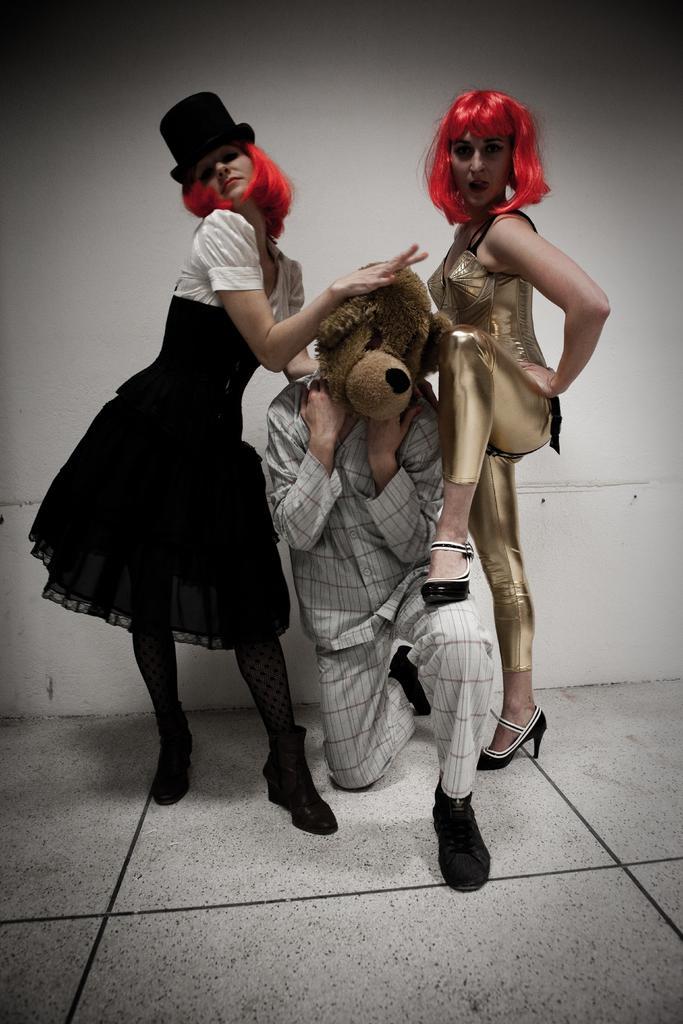Can you describe this image briefly? In this image I can see three persons, in front the person is wearing mask which is in brown color and the person at right wearing brown color dress, and the person at left wearing black and white dress. Background I can see wall in white color. 